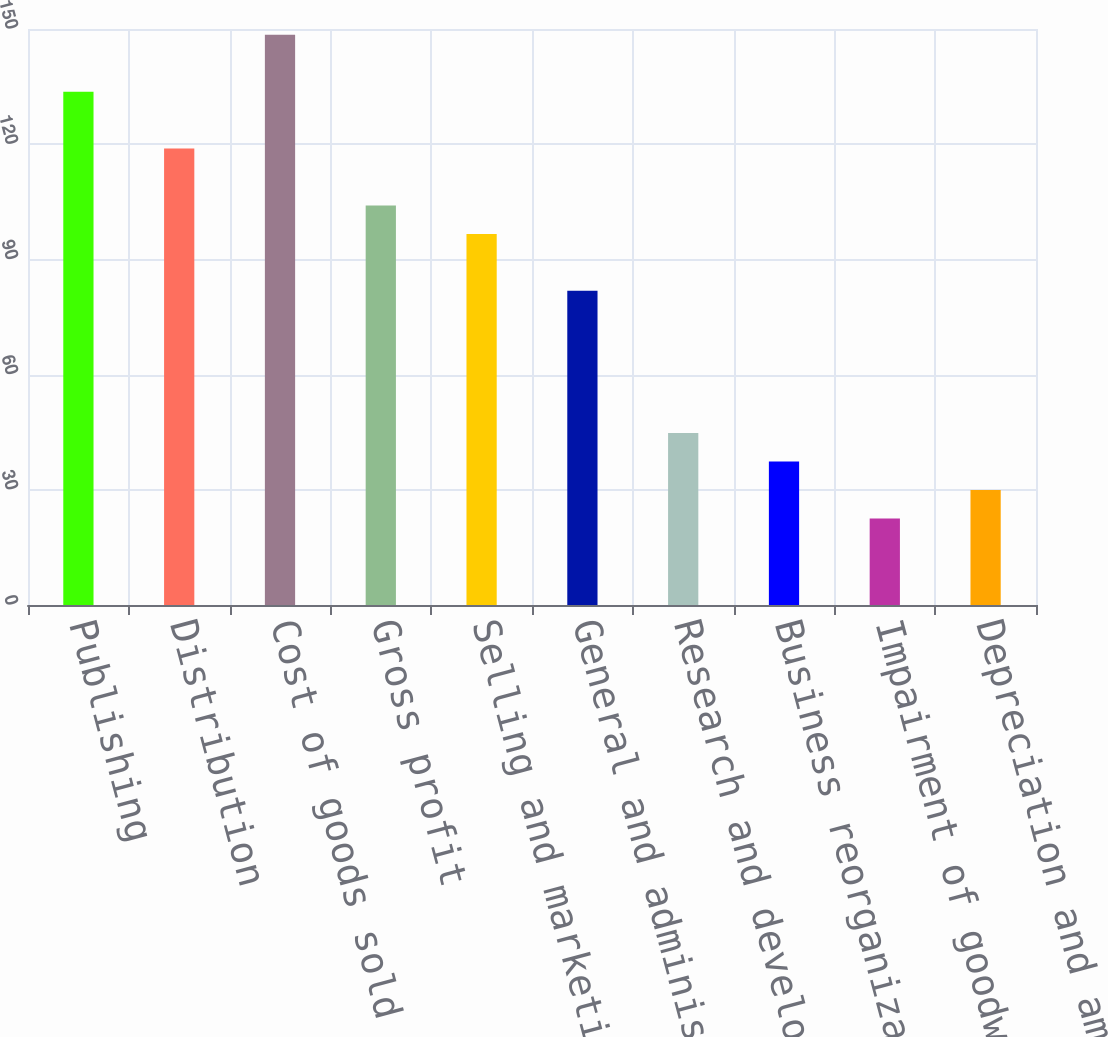Convert chart. <chart><loc_0><loc_0><loc_500><loc_500><bar_chart><fcel>Publishing<fcel>Distribution<fcel>Cost of goods sold<fcel>Gross profit<fcel>Selling and marketing<fcel>General and administrative<fcel>Research and development<fcel>Business reorganization and<fcel>Impairment of goodwill and<fcel>Depreciation and amortization<nl><fcel>133.68<fcel>118.86<fcel>148.5<fcel>104.04<fcel>96.63<fcel>81.81<fcel>44.76<fcel>37.35<fcel>22.53<fcel>29.94<nl></chart> 